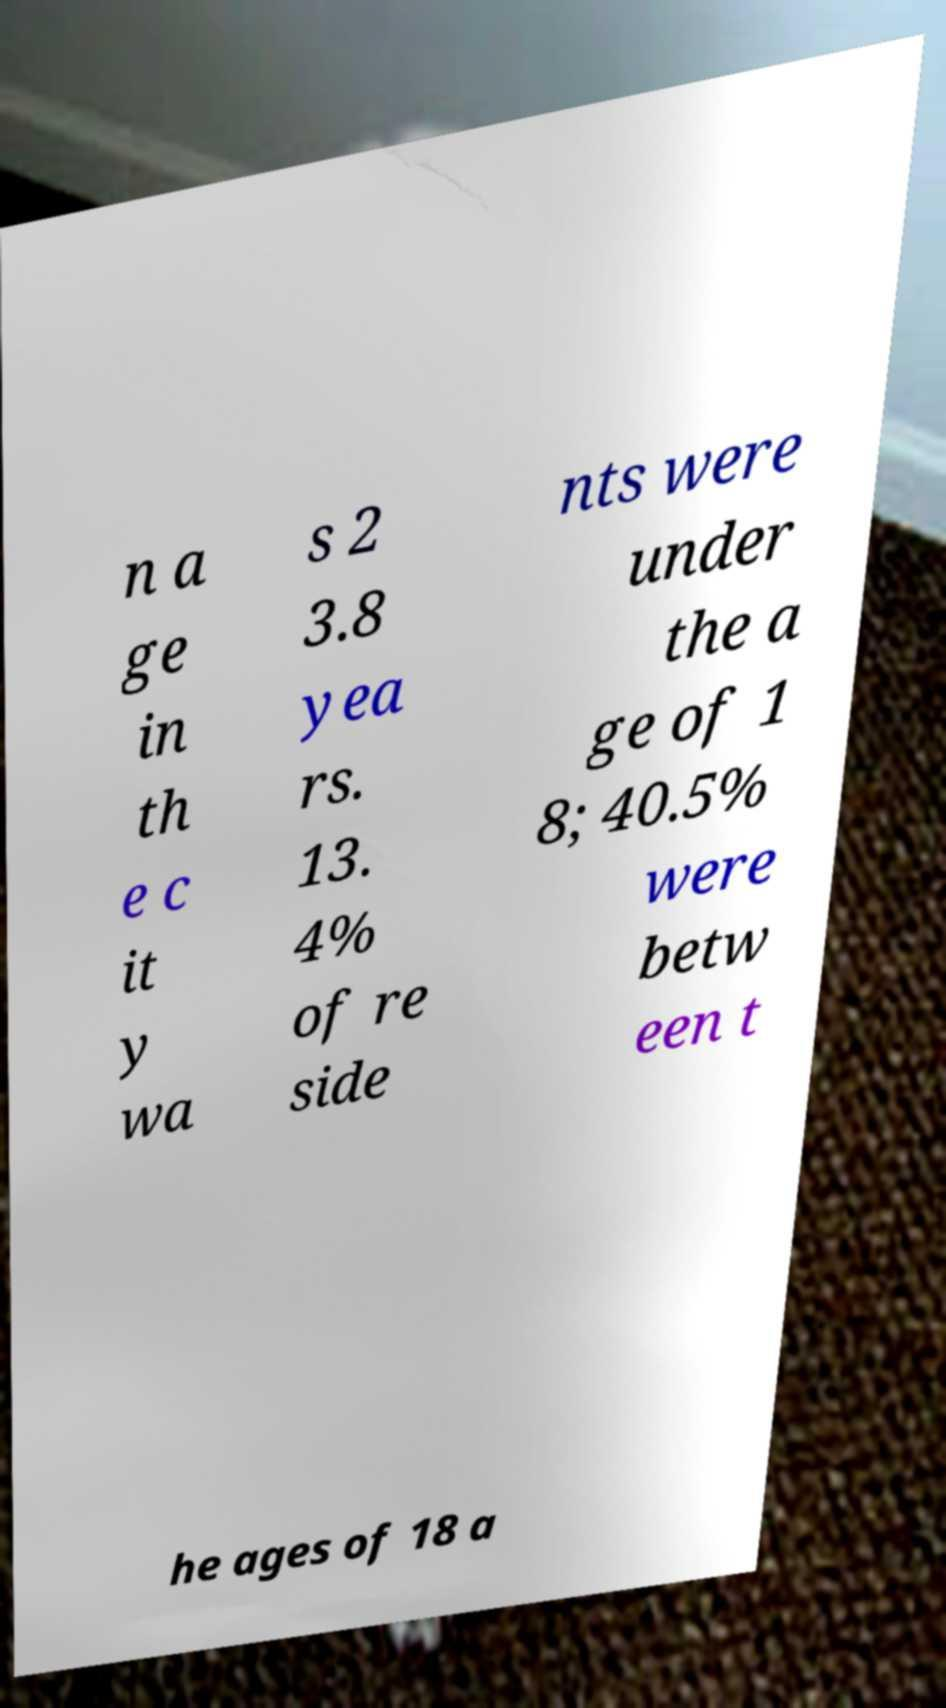What messages or text are displayed in this image? I need them in a readable, typed format. n a ge in th e c it y wa s 2 3.8 yea rs. 13. 4% of re side nts were under the a ge of 1 8; 40.5% were betw een t he ages of 18 a 